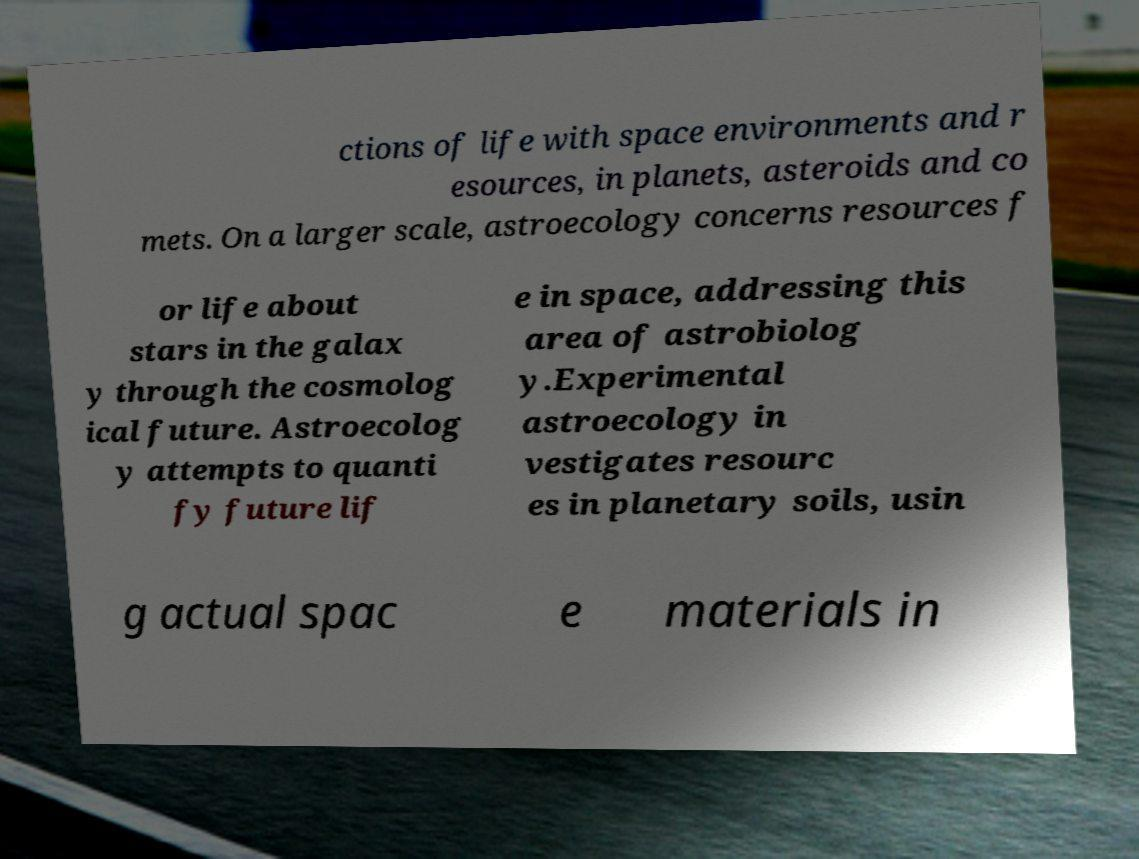Can you read and provide the text displayed in the image?This photo seems to have some interesting text. Can you extract and type it out for me? ctions of life with space environments and r esources, in planets, asteroids and co mets. On a larger scale, astroecology concerns resources f or life about stars in the galax y through the cosmolog ical future. Astroecolog y attempts to quanti fy future lif e in space, addressing this area of astrobiolog y.Experimental astroecology in vestigates resourc es in planetary soils, usin g actual spac e materials in 